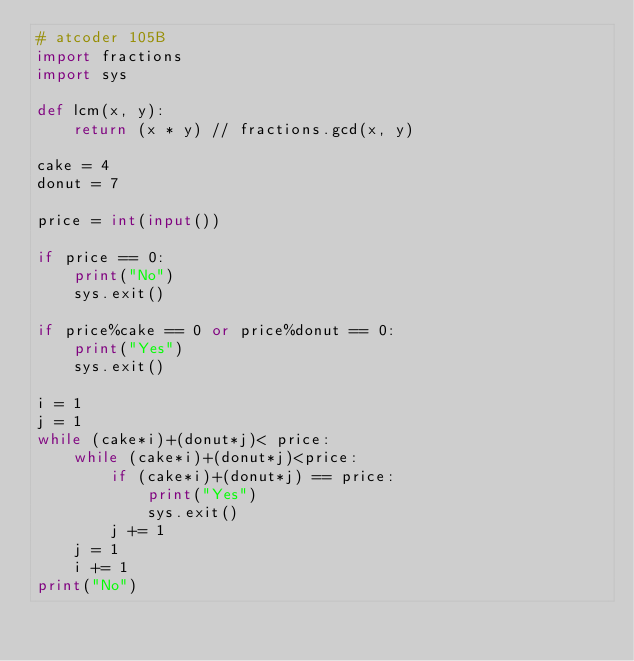Convert code to text. <code><loc_0><loc_0><loc_500><loc_500><_Python_># atcoder 105B
import fractions
import sys

def lcm(x, y):
    return (x * y) // fractions.gcd(x, y)

cake = 4
donut = 7

price = int(input())

if price == 0:
    print("No")
    sys.exit()

if price%cake == 0 or price%donut == 0:
    print("Yes")
    sys.exit()

i = 1
j = 1
while (cake*i)+(donut*j)< price:
    while (cake*i)+(donut*j)<price:
        if (cake*i)+(donut*j) == price:
            print("Yes")
            sys.exit()
        j += 1
    j = 1
    i += 1
print("No")</code> 